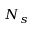Convert formula to latex. <formula><loc_0><loc_0><loc_500><loc_500>N _ { s }</formula> 